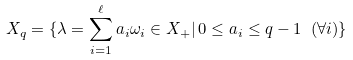Convert formula to latex. <formula><loc_0><loc_0><loc_500><loc_500>X _ { q } = \{ \lambda = \sum _ { i = 1 } ^ { \ell } a _ { i } \omega _ { i } \in X _ { + } | \, 0 \leq a _ { i } \leq q - 1 \ ( \forall i ) \}</formula> 